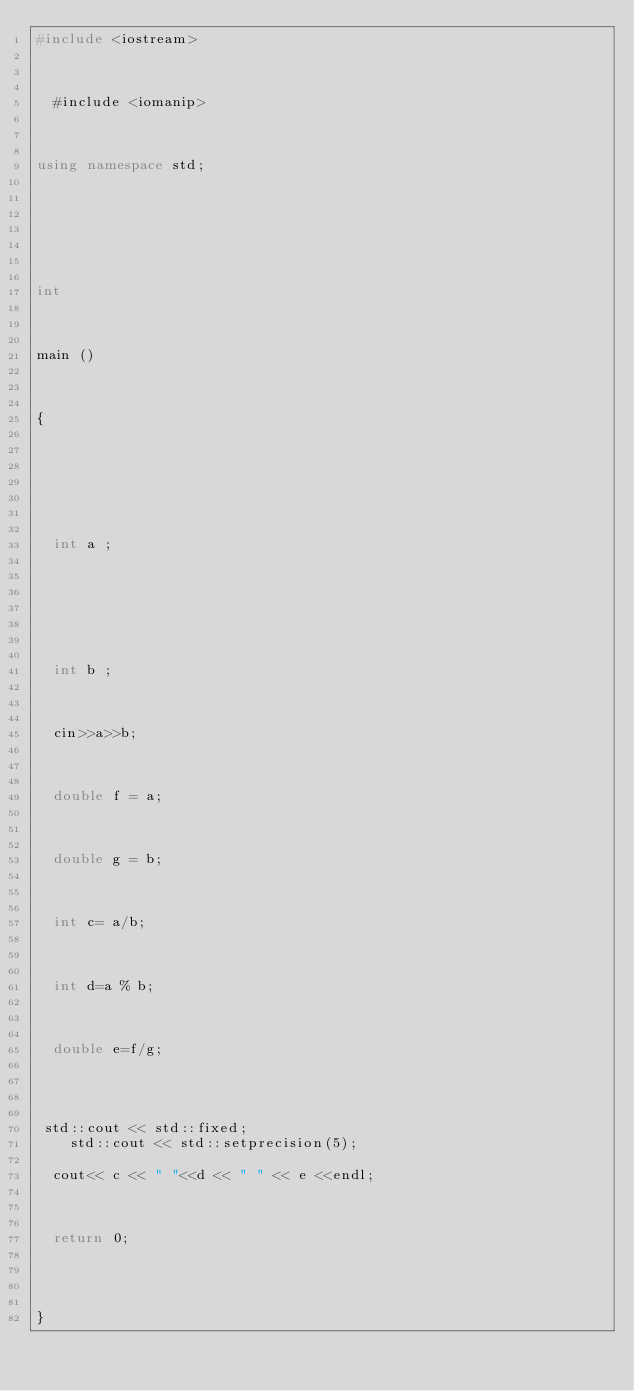<code> <loc_0><loc_0><loc_500><loc_500><_C++_>#include <iostream> 

 

  #include <iomanip>

 

using namespace std; 

 

  

 

int 

 

main () 

 

{ 

 

  

 

  int a ; 

 

  

 

  int b ; 

 

  cin>>a>>b; 

 

  double f = a; 

 

  double g = b; 

 

  int c= a/b; 

 

  int d=a % b; 

 

  double e=f/g; 

 

   
 std::cout << std::fixed;
    std::cout << std::setprecision(5);
    
  cout<< c << " "<<d << " " << e <<endl; 

 

  return 0; 

 

 
} 
</code> 